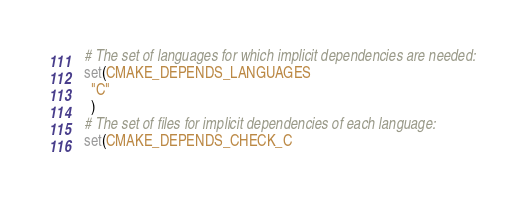Convert code to text. <code><loc_0><loc_0><loc_500><loc_500><_CMake_># The set of languages for which implicit dependencies are needed:
set(CMAKE_DEPENDS_LANGUAGES
  "C"
  )
# The set of files for implicit dependencies of each language:
set(CMAKE_DEPENDS_CHECK_C</code> 